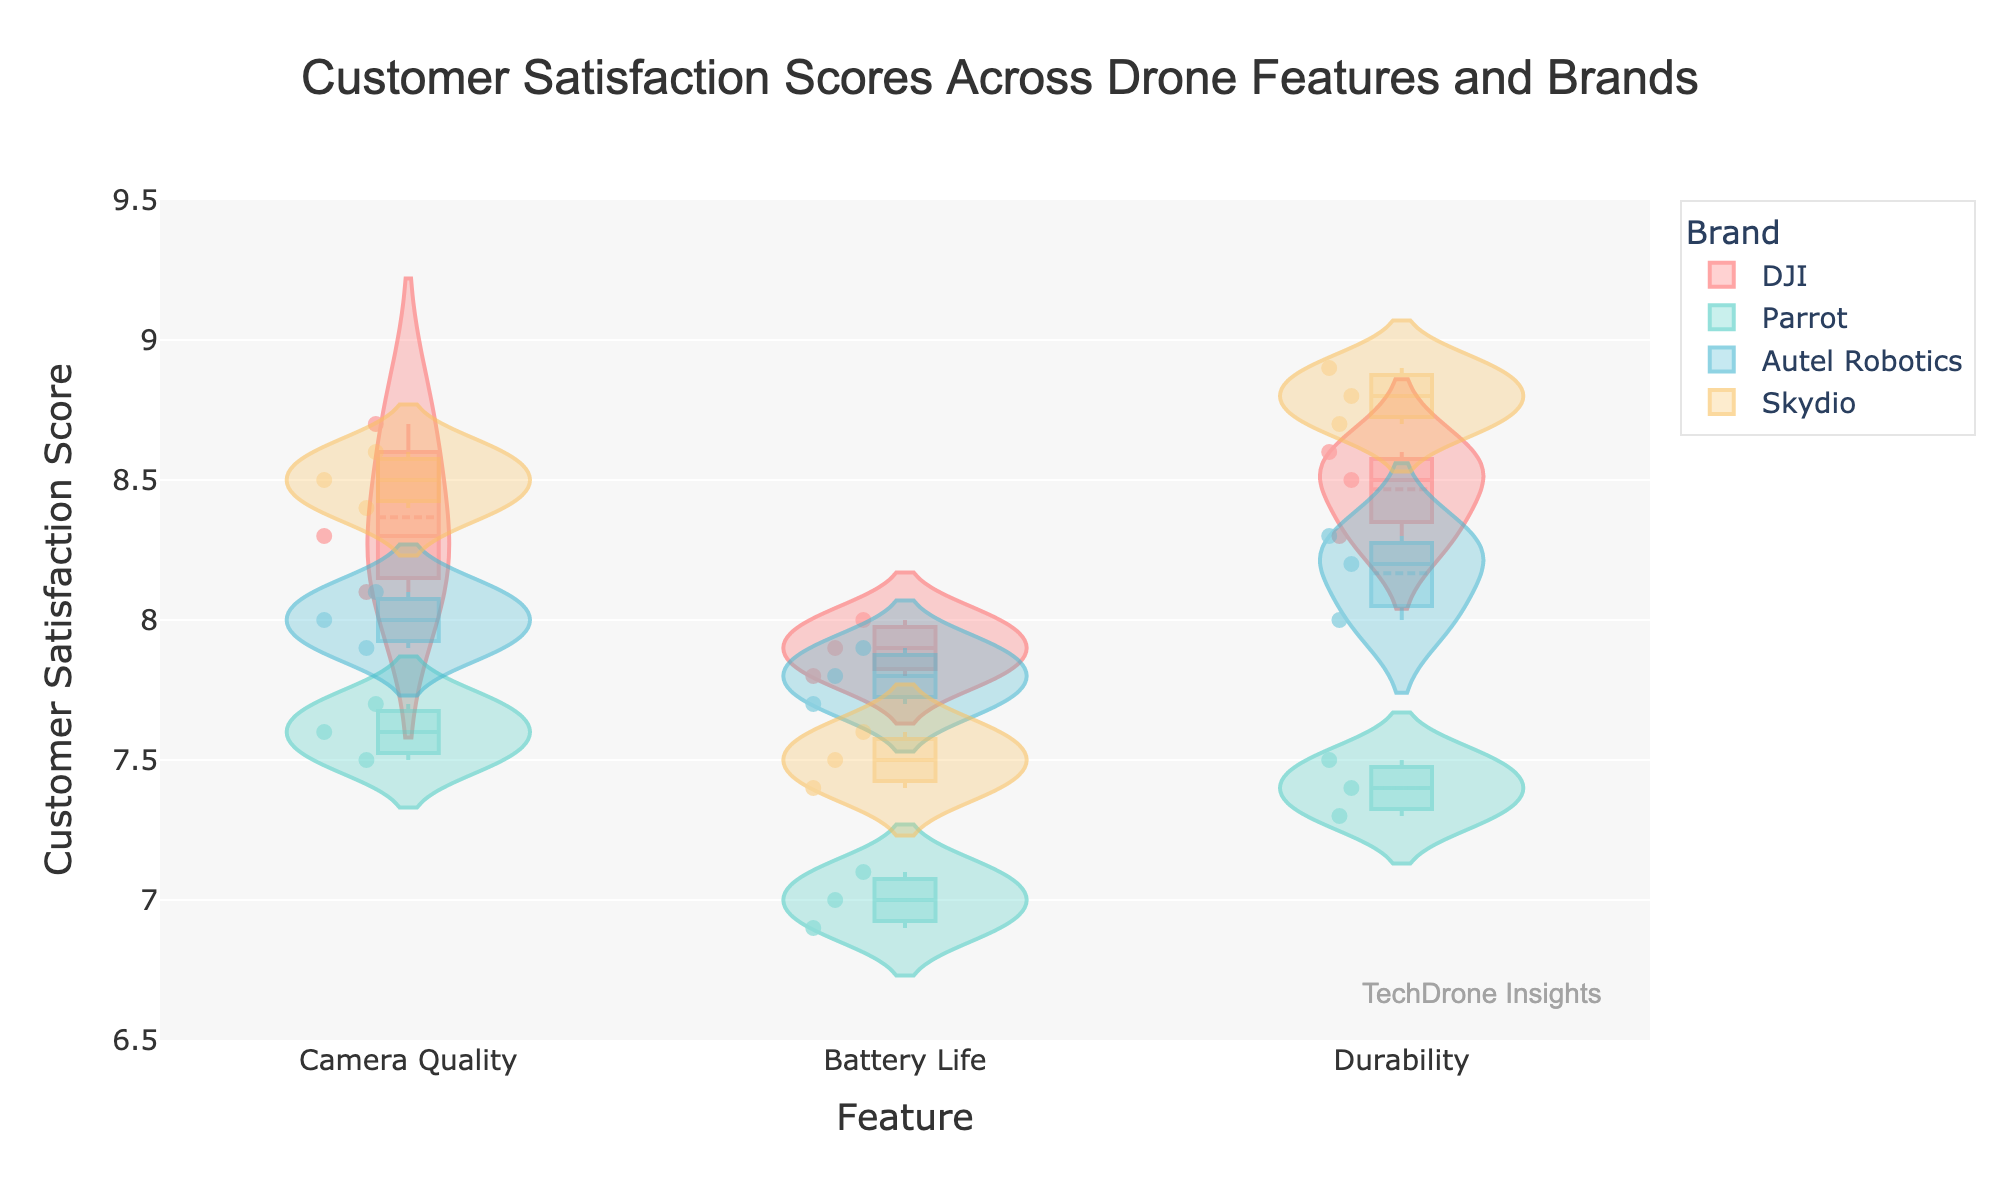Which brand has the highest average customer satisfaction score for Camera Quality? To find the highest average score for Camera Quality among the brands, we look at the box plots overlaid on the violin plots. Skydio's average score is higher than other brands.
Answer: Skydio Which feature has the lowest customer satisfaction scores overall? By examining the violin plots, Battery Life has the lowest scores across all brands, visible from the lower position of the box plots.
Answer: Battery Life What is the range of customer satisfaction scores for DJI's Durability feature? The range is the difference between the highest and lowest score. For DJI's Durability, the highest score is 8.6 and the lowest is 8.3, giving a range of 8.6 - 8.3.
Answer: 0.3 How do the distributions of customer satisfaction scores for Battery Life differ between Parrot and Skydio? Comparing the violin plots, Skydio's Battery Life scores are higher and more concentrated around the mean, while Parrot's scores are lower with more spread.
Answer: Skydio's are higher and more concentrated; Parrot's are lower and more spread Which brand has the most consistent customer satisfaction scores for Camera Quality? Consistency can be inferred from the narrowness and the closeness of the points in the violin plot. DJI has the narrowest distribution, indicating the most consistent scores.
Answer: DJI What is the median customer satisfaction score for Autel Robotics' Battery Life? The median is the middle point of the box plot for Battery Life under Autel Robotics. This value is around 7.8.
Answer: 7.8 Are there any outliers in the customer satisfaction scores for Skydio's Durability? Outliers typically appear as individual points outside the main distribution. For Skydio's Durability, there are no points away from the main cluster, indicating no outliers.
Answer: No Which brand has the highest variability in customer satisfaction scores for Battery Life? Variability can be assessed by the spread of the violin plot. Parrot's Battery Life shows the highest variability, indicated by a wider spread of scores.
Answer: Parrot How does the mean customer satisfaction score for DJI's Camera Quality compare to Autel Robotics'? Mean is indicated by the thin horizontal line within the box plot. DJI's mean score for Camera Quality is slightly higher than Autel Robotics'.
Answer: DJI's is higher What is the interquartile range (IQR) for Parrot's Durability scores? The IQR is the range between the 25th and 75th percentiles, shown by the box in the box plot. For Parrot's Durability, this range is from around 7.3 to 7.5, giving an IQR of 7.5 - 7.3.
Answer: 0.2 